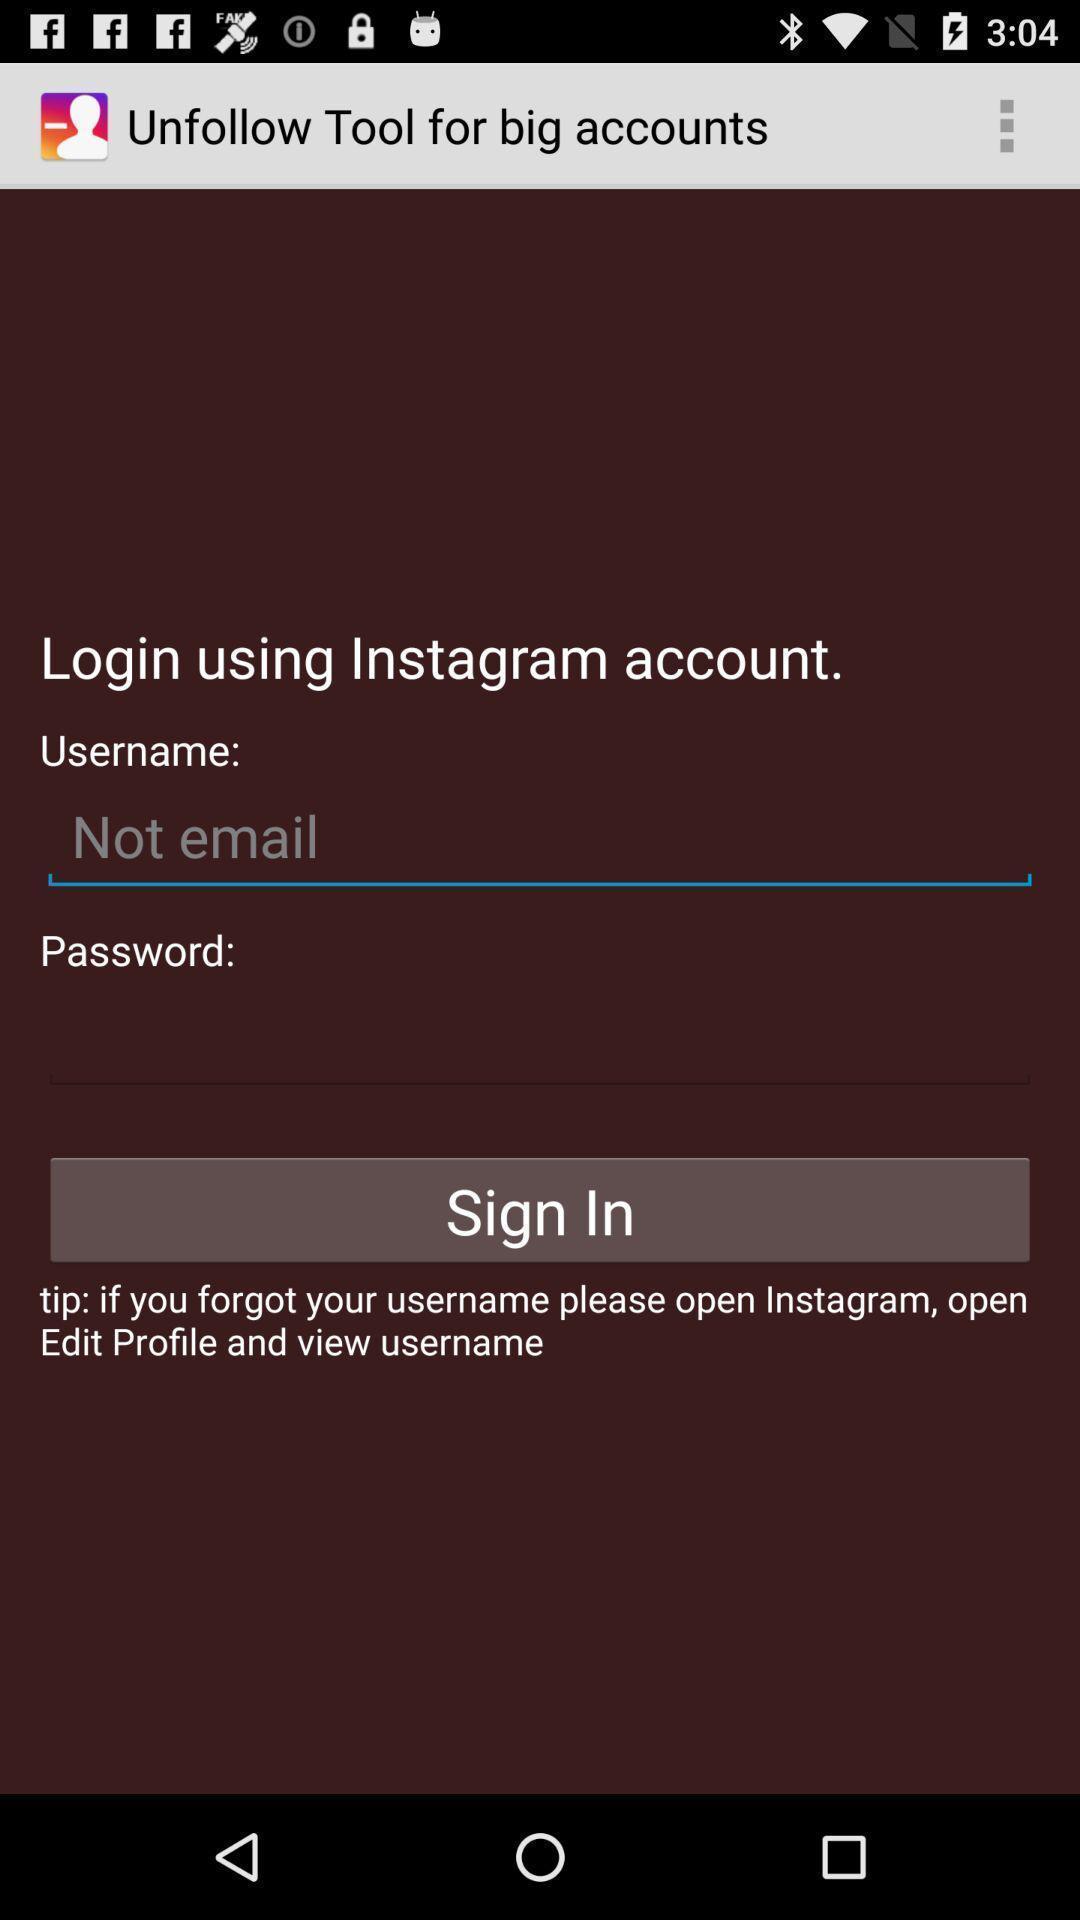Tell me about the visual elements in this screen capture. Sign in page. 